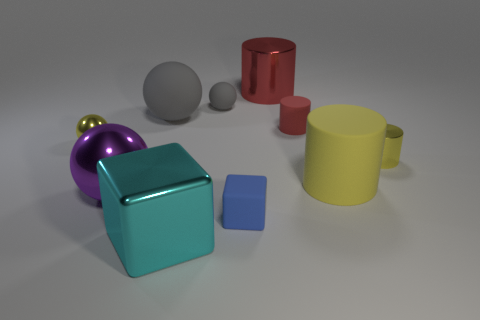Subtract all cylinders. How many objects are left? 6 Add 9 red metallic cylinders. How many red metallic cylinders exist? 10 Subtract 0 gray cubes. How many objects are left? 10 Subtract all tiny cyan matte cylinders. Subtract all big purple spheres. How many objects are left? 9 Add 8 yellow metallic cylinders. How many yellow metallic cylinders are left? 9 